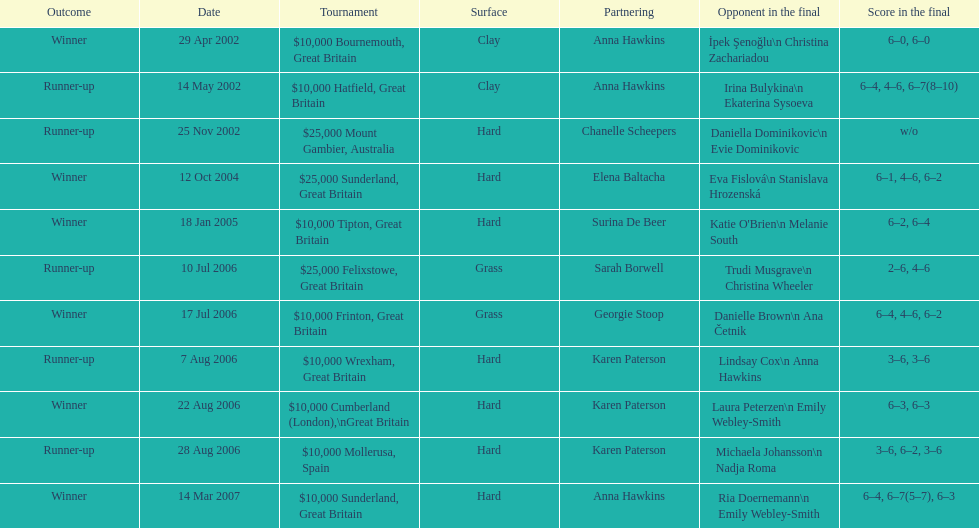Would you mind parsing the complete table? {'header': ['Outcome', 'Date', 'Tournament', 'Surface', 'Partnering', 'Opponent in the final', 'Score in the final'], 'rows': [['Winner', '29 Apr 2002', '$10,000 Bournemouth, Great Britain', 'Clay', 'Anna Hawkins', 'İpek Şenoğlu\\n Christina Zachariadou', '6–0, 6–0'], ['Runner-up', '14 May 2002', '$10,000 Hatfield, Great Britain', 'Clay', 'Anna Hawkins', 'Irina Bulykina\\n Ekaterina Sysoeva', '6–4, 4–6, 6–7(8–10)'], ['Runner-up', '25 Nov 2002', '$25,000 Mount Gambier, Australia', 'Hard', 'Chanelle Scheepers', 'Daniella Dominikovic\\n Evie Dominikovic', 'w/o'], ['Winner', '12 Oct 2004', '$25,000 Sunderland, Great Britain', 'Hard', 'Elena Baltacha', 'Eva Fislová\\n Stanislava Hrozenská', '6–1, 4–6, 6–2'], ['Winner', '18 Jan 2005', '$10,000 Tipton, Great Britain', 'Hard', 'Surina De Beer', "Katie O'Brien\\n Melanie South", '6–2, 6–4'], ['Runner-up', '10 Jul 2006', '$25,000 Felixstowe, Great Britain', 'Grass', 'Sarah Borwell', 'Trudi Musgrave\\n Christina Wheeler', '2–6, 4–6'], ['Winner', '17 Jul 2006', '$10,000 Frinton, Great Britain', 'Grass', 'Georgie Stoop', 'Danielle Brown\\n Ana Četnik', '6–4, 4–6, 6–2'], ['Runner-up', '7 Aug 2006', '$10,000 Wrexham, Great Britain', 'Hard', 'Karen Paterson', 'Lindsay Cox\\n Anna Hawkins', '3–6, 3–6'], ['Winner', '22 Aug 2006', '$10,000 Cumberland (London),\\nGreat Britain', 'Hard', 'Karen Paterson', 'Laura Peterzen\\n Emily Webley-Smith', '6–3, 6–3'], ['Runner-up', '28 Aug 2006', '$10,000 Mollerusa, Spain', 'Hard', 'Karen Paterson', 'Michaela Johansson\\n Nadja Roma', '3–6, 6–2, 3–6'], ['Winner', '14 Mar 2007', '$10,000 Sunderland, Great Britain', 'Hard', 'Anna Hawkins', 'Ria Doernemann\\n Emily Webley-Smith', '6–4, 6–7(5–7), 6–3']]} How many were played on a hard surface? 7. 